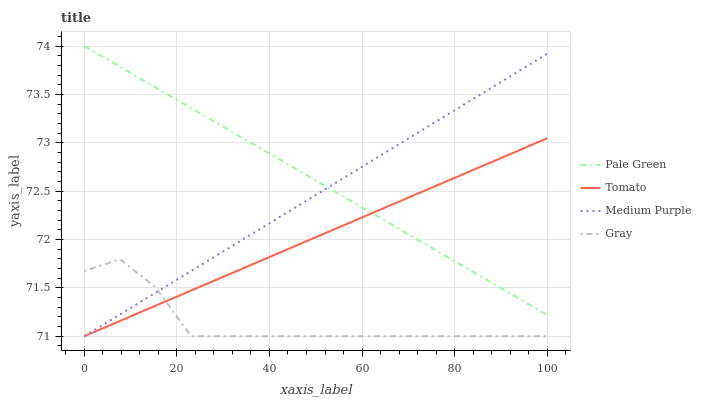Does Gray have the minimum area under the curve?
Answer yes or no. Yes. Does Pale Green have the maximum area under the curve?
Answer yes or no. Yes. Does Medium Purple have the minimum area under the curve?
Answer yes or no. No. Does Medium Purple have the maximum area under the curve?
Answer yes or no. No. Is Tomato the smoothest?
Answer yes or no. Yes. Is Gray the roughest?
Answer yes or no. Yes. Is Medium Purple the smoothest?
Answer yes or no. No. Is Medium Purple the roughest?
Answer yes or no. No. Does Tomato have the lowest value?
Answer yes or no. Yes. Does Pale Green have the lowest value?
Answer yes or no. No. Does Pale Green have the highest value?
Answer yes or no. Yes. Does Medium Purple have the highest value?
Answer yes or no. No. Is Gray less than Pale Green?
Answer yes or no. Yes. Is Pale Green greater than Gray?
Answer yes or no. Yes. Does Pale Green intersect Tomato?
Answer yes or no. Yes. Is Pale Green less than Tomato?
Answer yes or no. No. Is Pale Green greater than Tomato?
Answer yes or no. No. Does Gray intersect Pale Green?
Answer yes or no. No. 